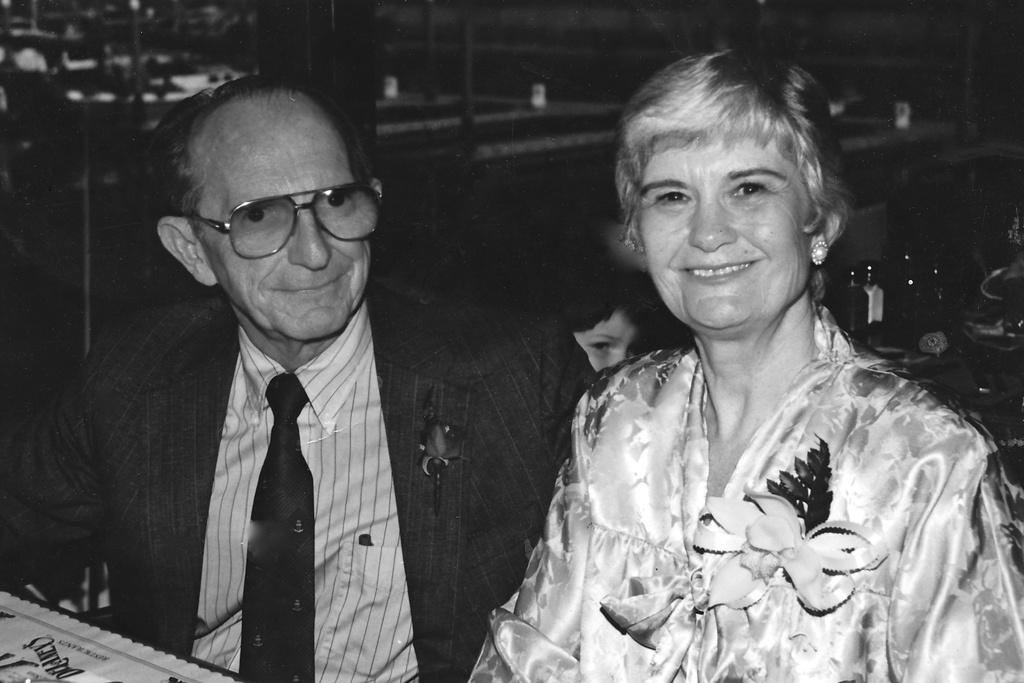In one or two sentences, can you explain what this image depicts? This is a black and white picture. I can see a man and a woman smiling, there are some objects, there is a person head behind the man and a woman, and there is blur background. 